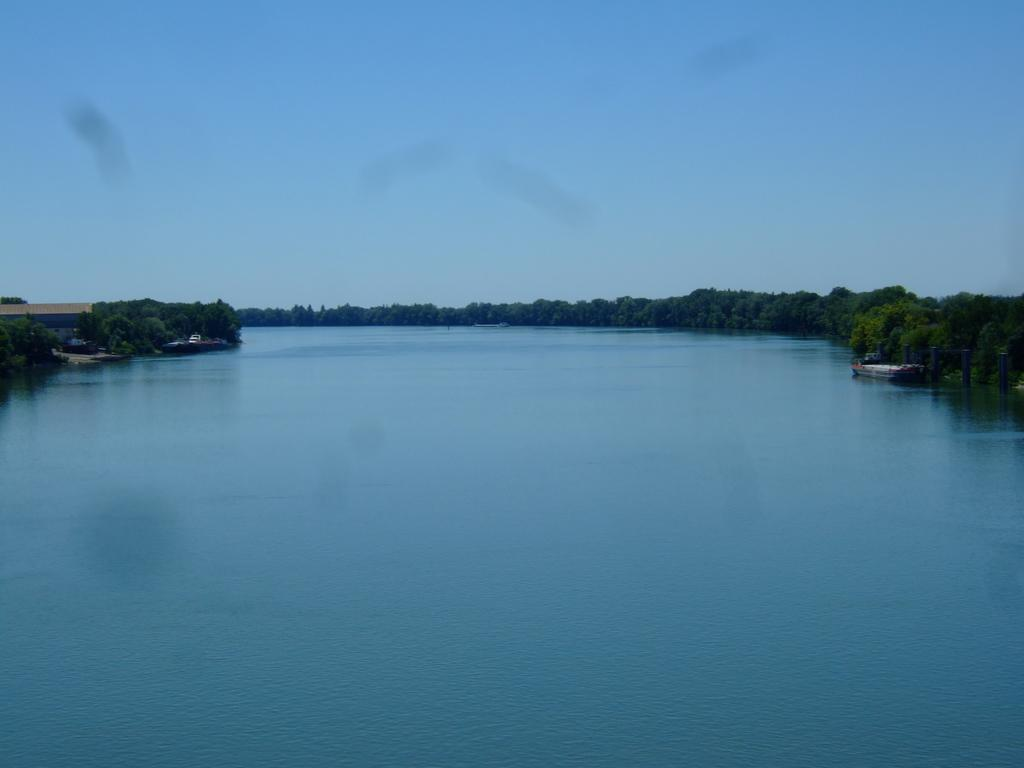What is the main feature of the image? The main feature of the image is water. What can be seen floating on the water? There is a boat in the image. What type of vegetation is visible in the image? There are trees in the image. What type of structure is present in the image? There is a shed in the image. What is the color of the sky in the image? The sky is blue in color. Where is the flame located in the image? There is no flame present in the image. What type of control is used to operate the boat in the image? The image does not show the boat being operated, so it is not possible to determine the type of control used. 